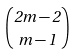Convert formula to latex. <formula><loc_0><loc_0><loc_500><loc_500>\binom { 2 m - 2 } { m - 1 }</formula> 